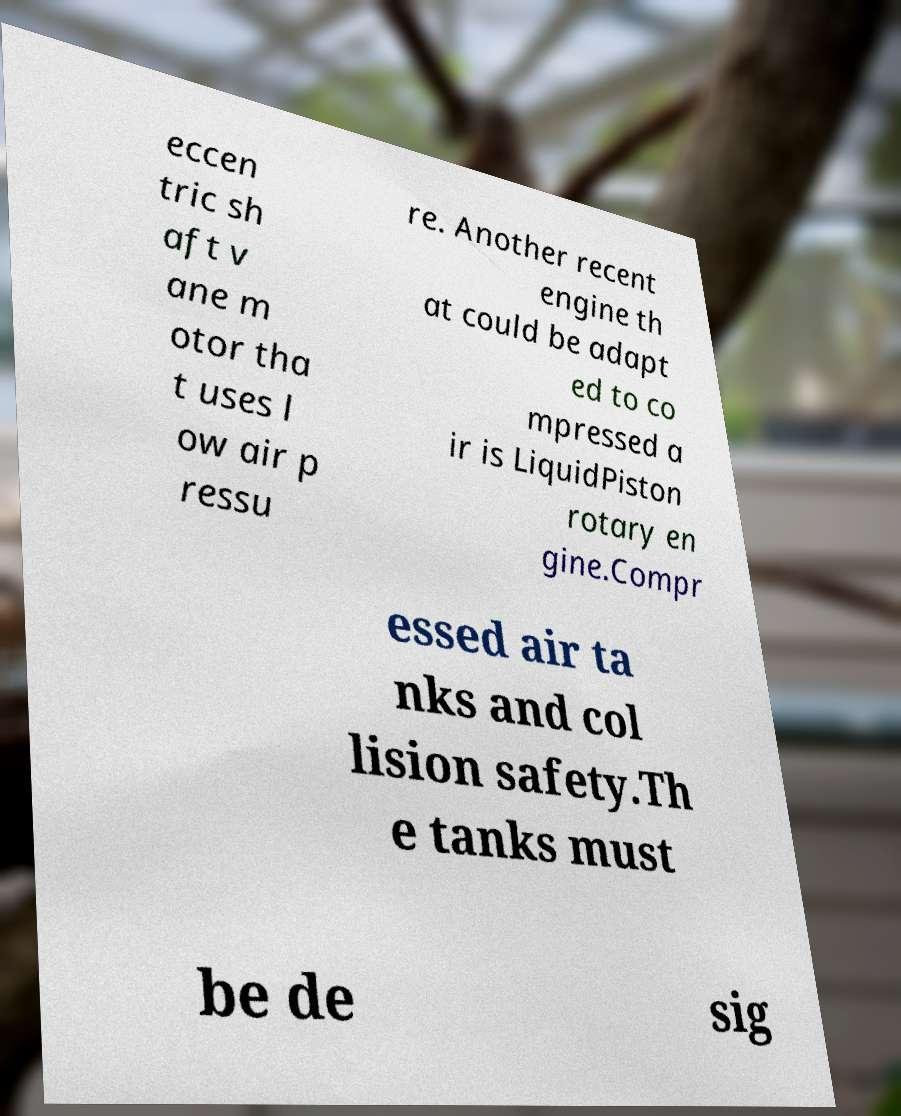Can you accurately transcribe the text from the provided image for me? eccen tric sh aft v ane m otor tha t uses l ow air p ressu re. Another recent engine th at could be adapt ed to co mpressed a ir is LiquidPiston rotary en gine.Compr essed air ta nks and col lision safety.Th e tanks must be de sig 